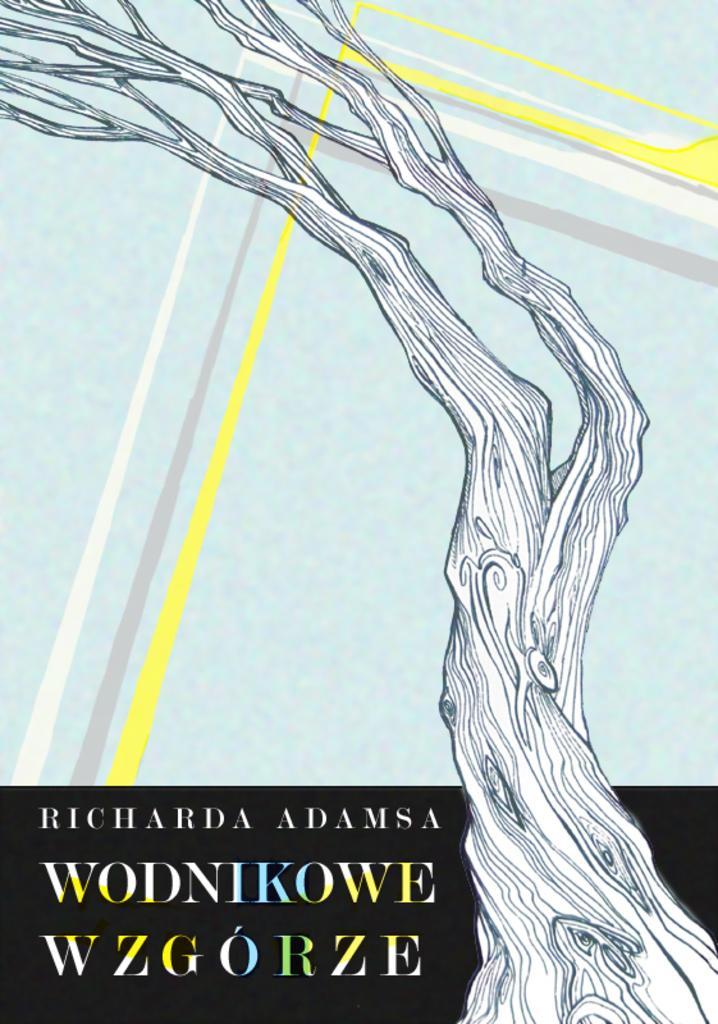Describe this image in one or two sentences. This picture shows a cartoon image of tree´s trunk and some branches, beside of this tree there is a printed letters. 